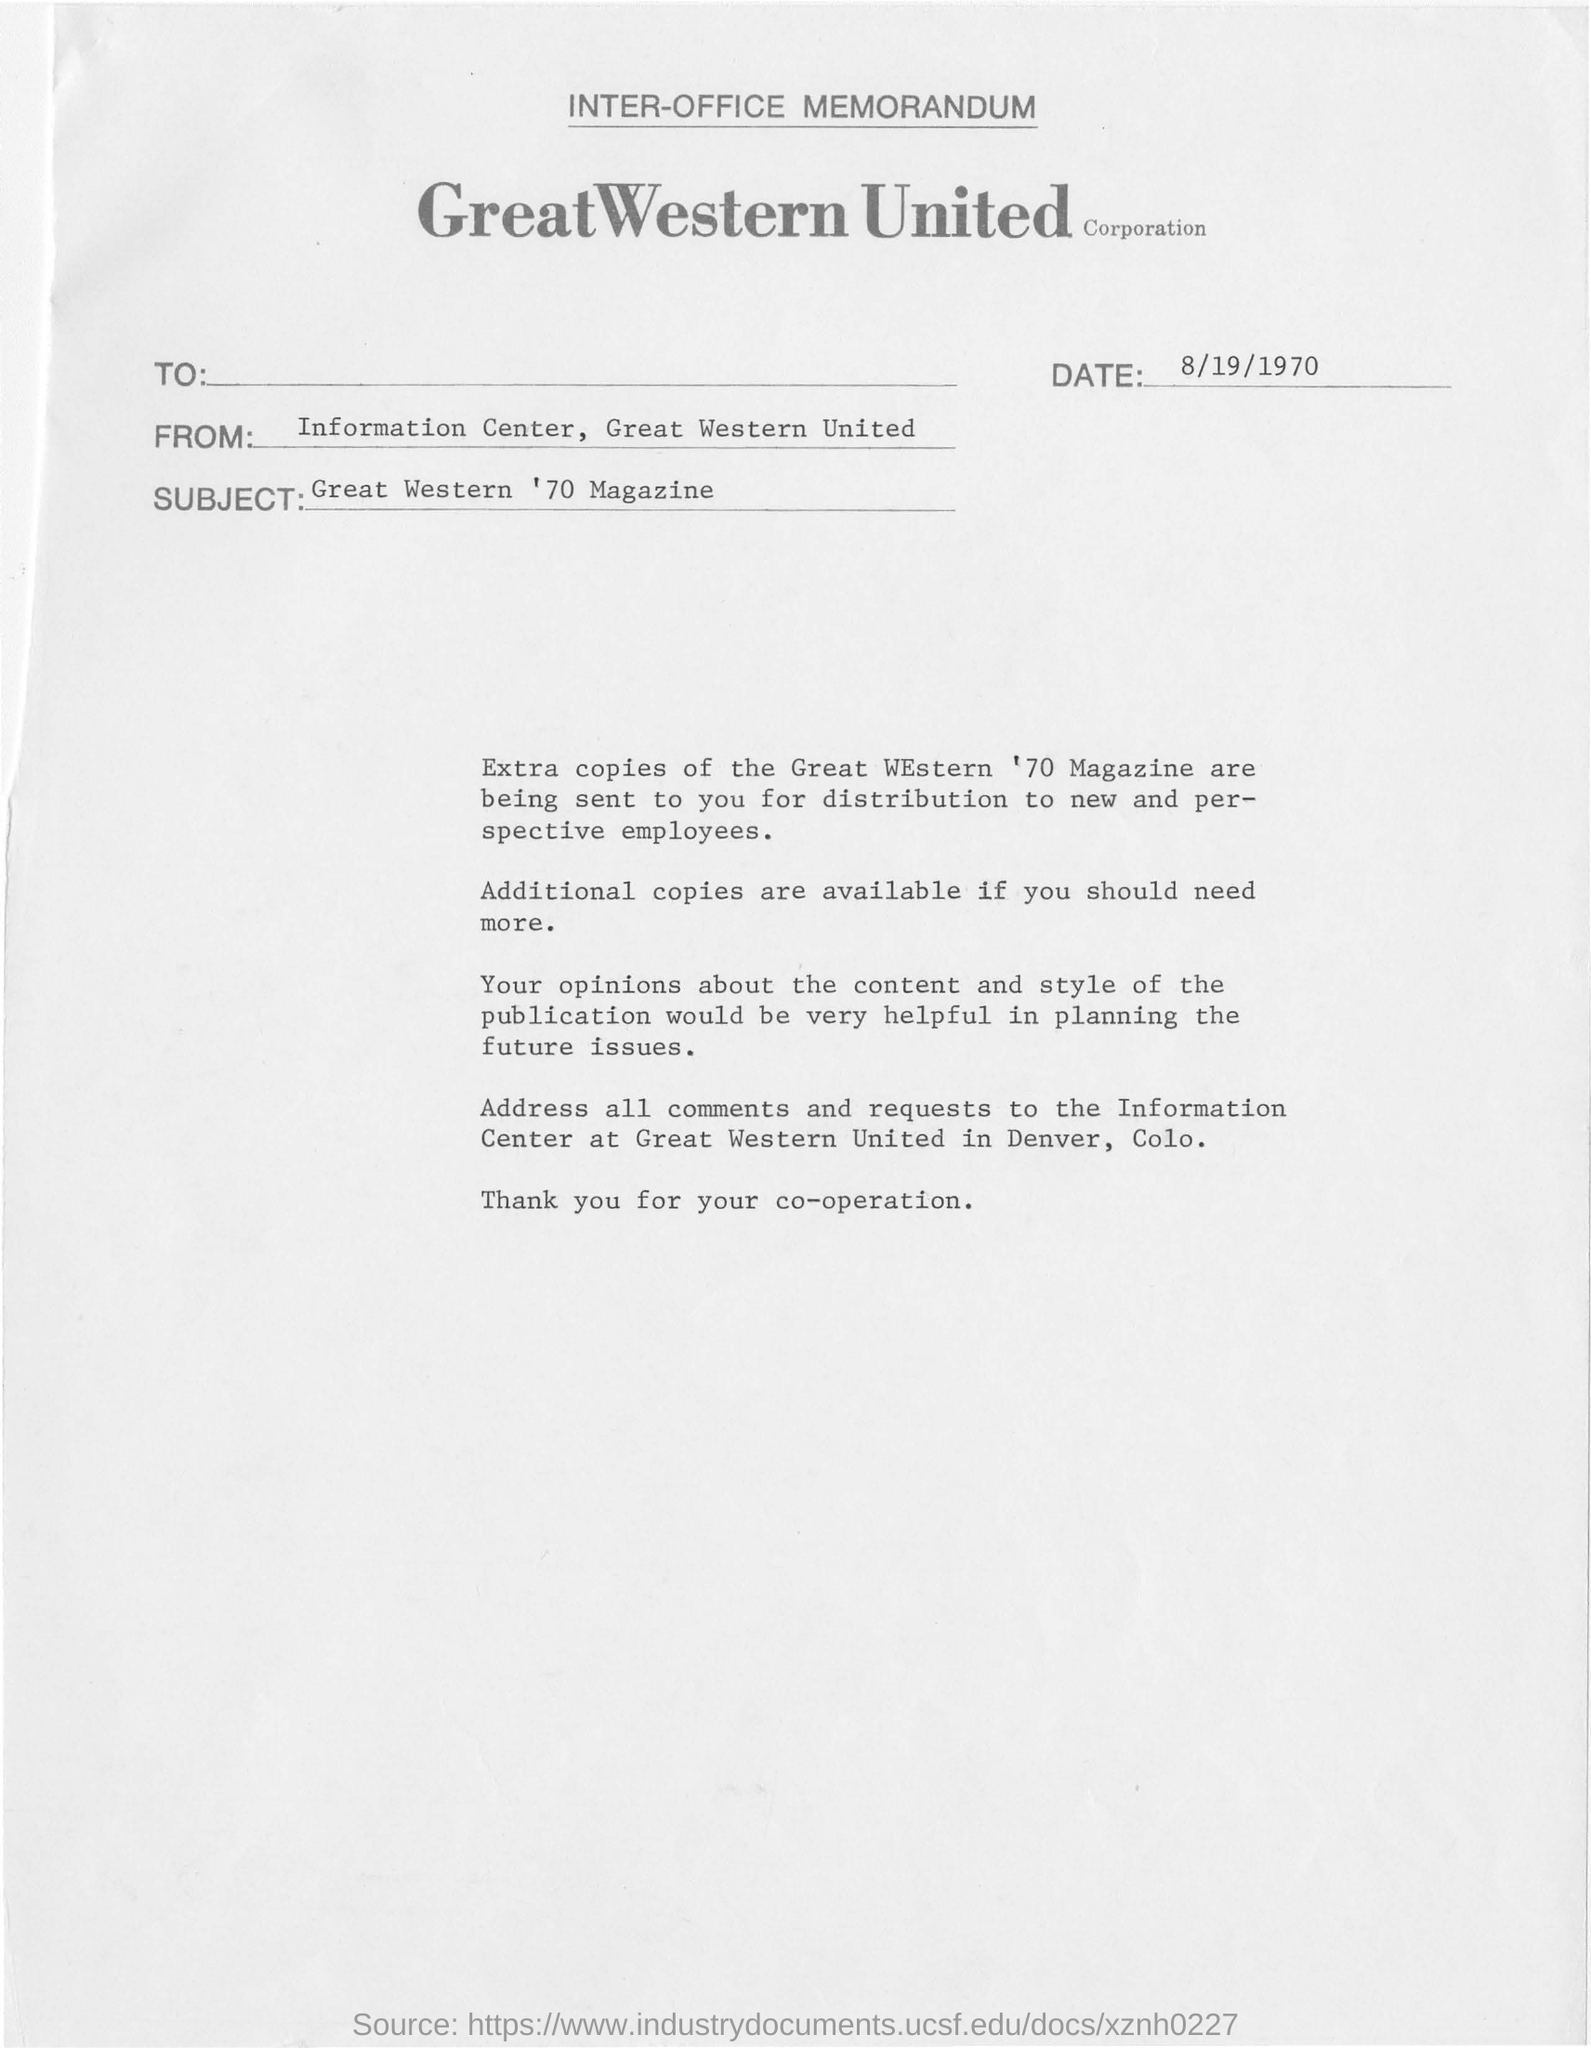What is the subject of the memorandum?
Offer a very short reply. Great Western '70 Magazine. What is the date on the memorandum?
Make the answer very short. 8/19/1970. Who is the memorandum from?
Give a very brief answer. Information Center, Great Western United. 